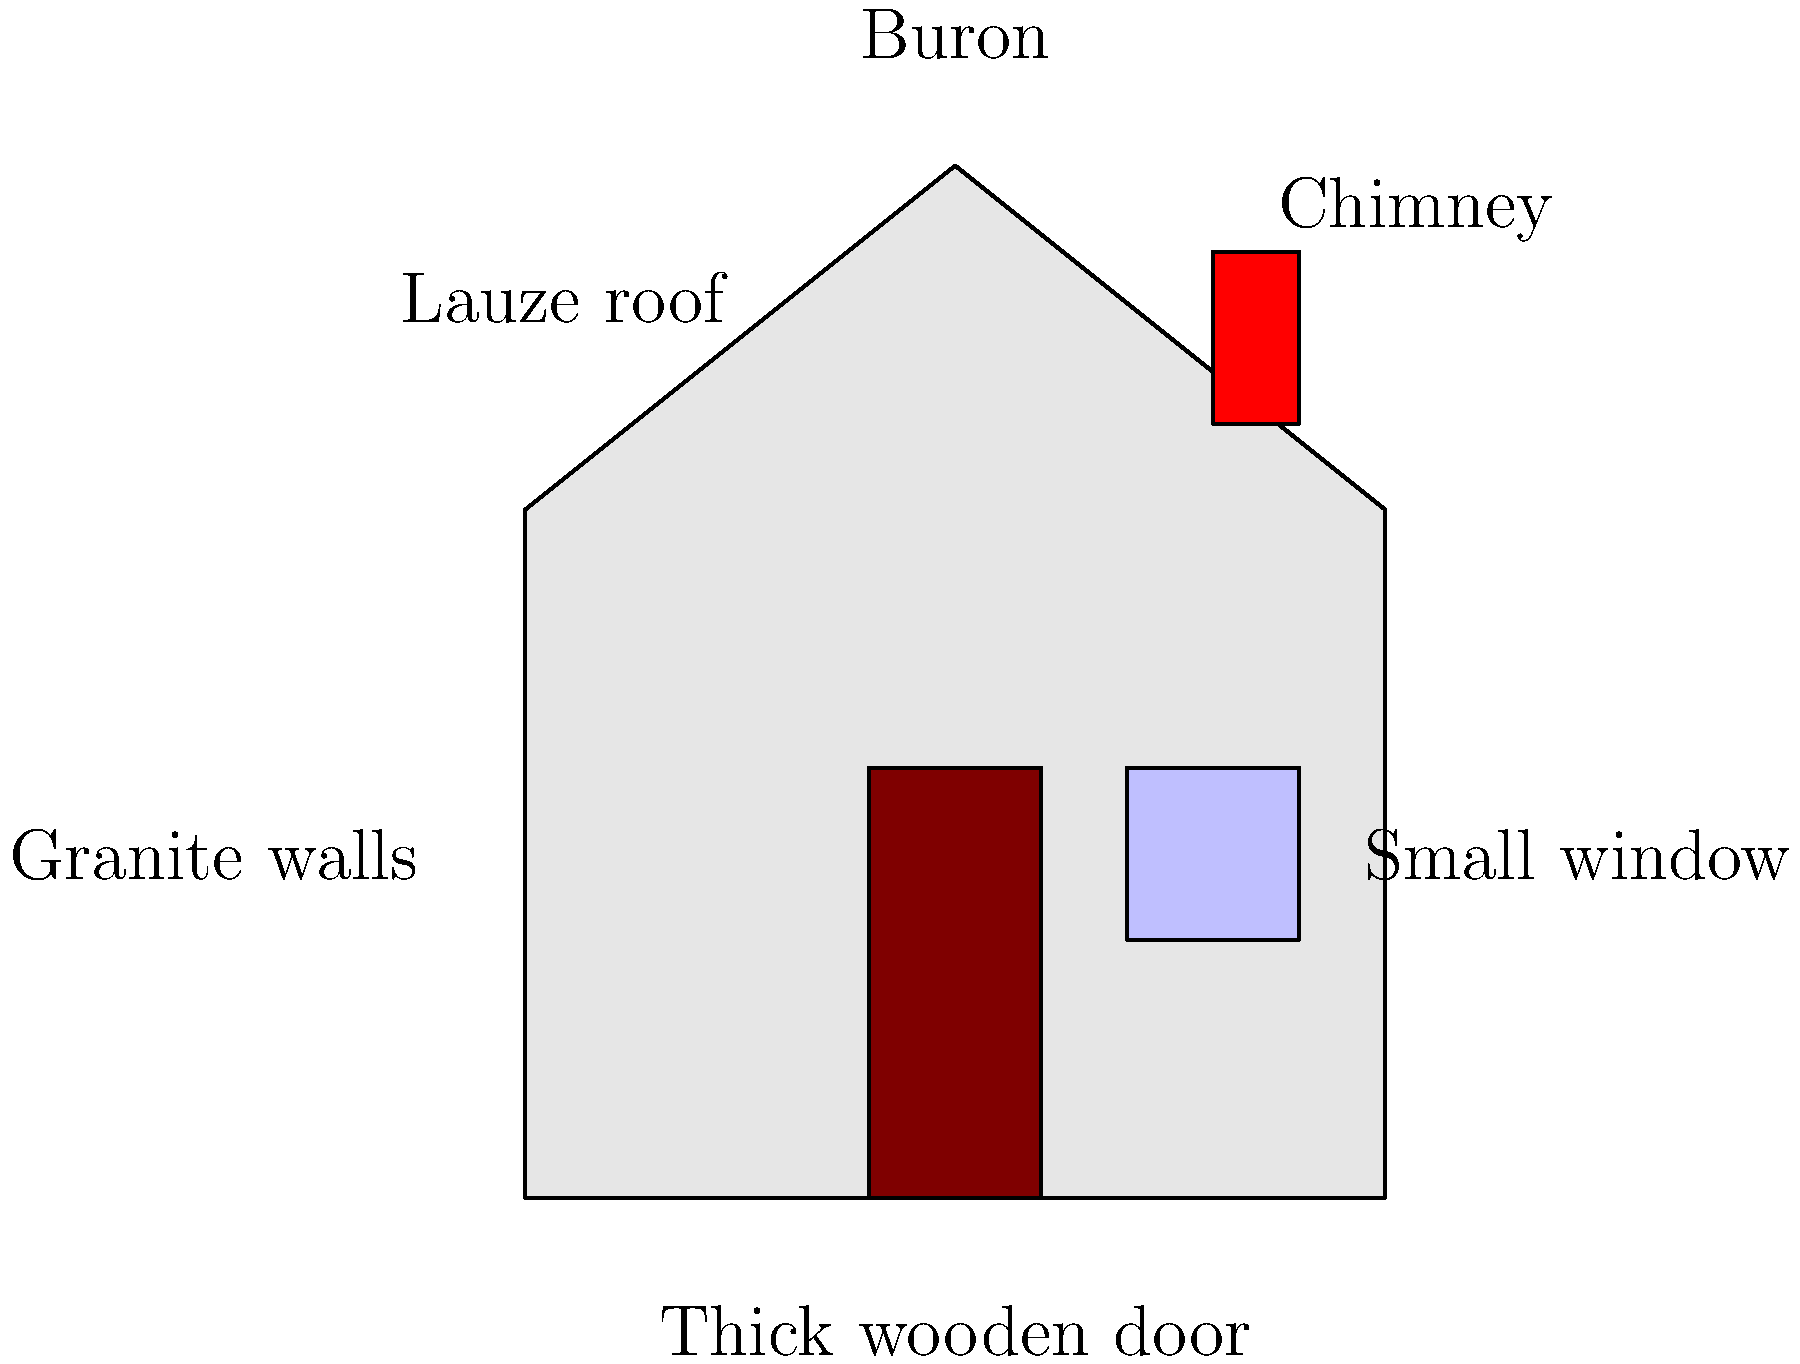Identify the primary roofing material used in traditional Cantalian houses, as shown in the labeled illustration of a typical "buron". To answer this question, let's examine the key architectural elements of a typical Cantalian house, known as a "buron":

1. The illustration shows a simple, sturdy structure typical of the Cantal region in France.

2. The house is labeled as a "Buron", which is a traditional pastoral dwelling found in the Auvergne region, particularly in Cantal.

3. The roof of the buron is distinctively sloped, forming a triangular shape when viewed from the side.

4. The label on the roof clearly indicates "Lauze roof".

5. Lauze is a type of flat stone, typically schist or phonolite, used for roofing in this region. It's known for its durability and ability to withstand harsh mountain weather conditions.

6. Other notable features of the buron include:
   - Granite walls, providing sturdy construction
   - A thick wooden door for insulation
   - A small window to minimize heat loss
   - A chimney for heating and cooking

7. The use of lauze for roofing is a characteristic feature of traditional architecture in Cantal, reflecting the region's geology and climate.

Therefore, the primary roofing material used in traditional Cantalian houses, as shown in the illustration, is lauze.
Answer: Lauze 